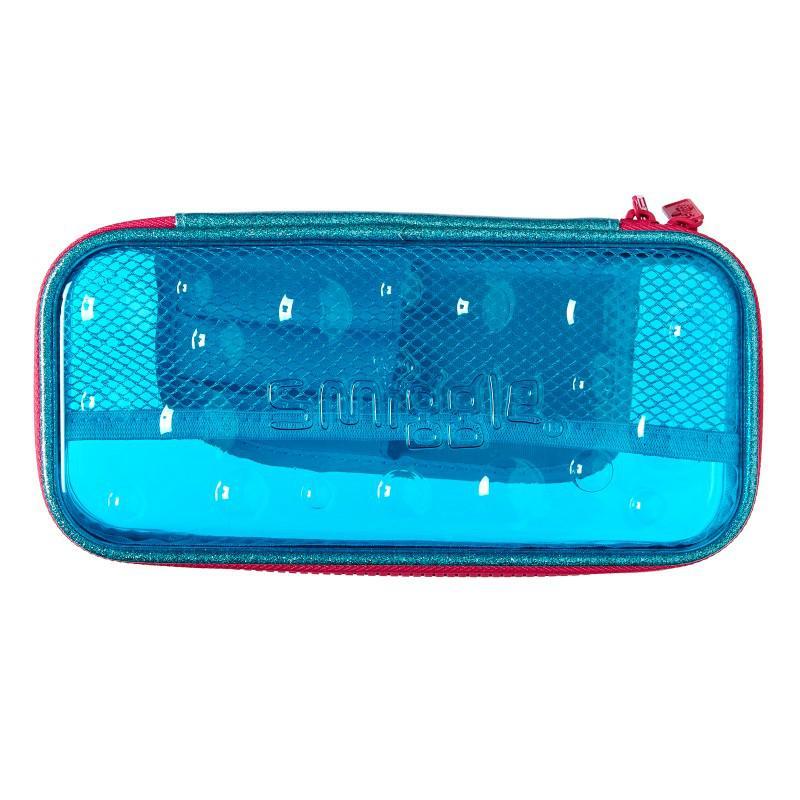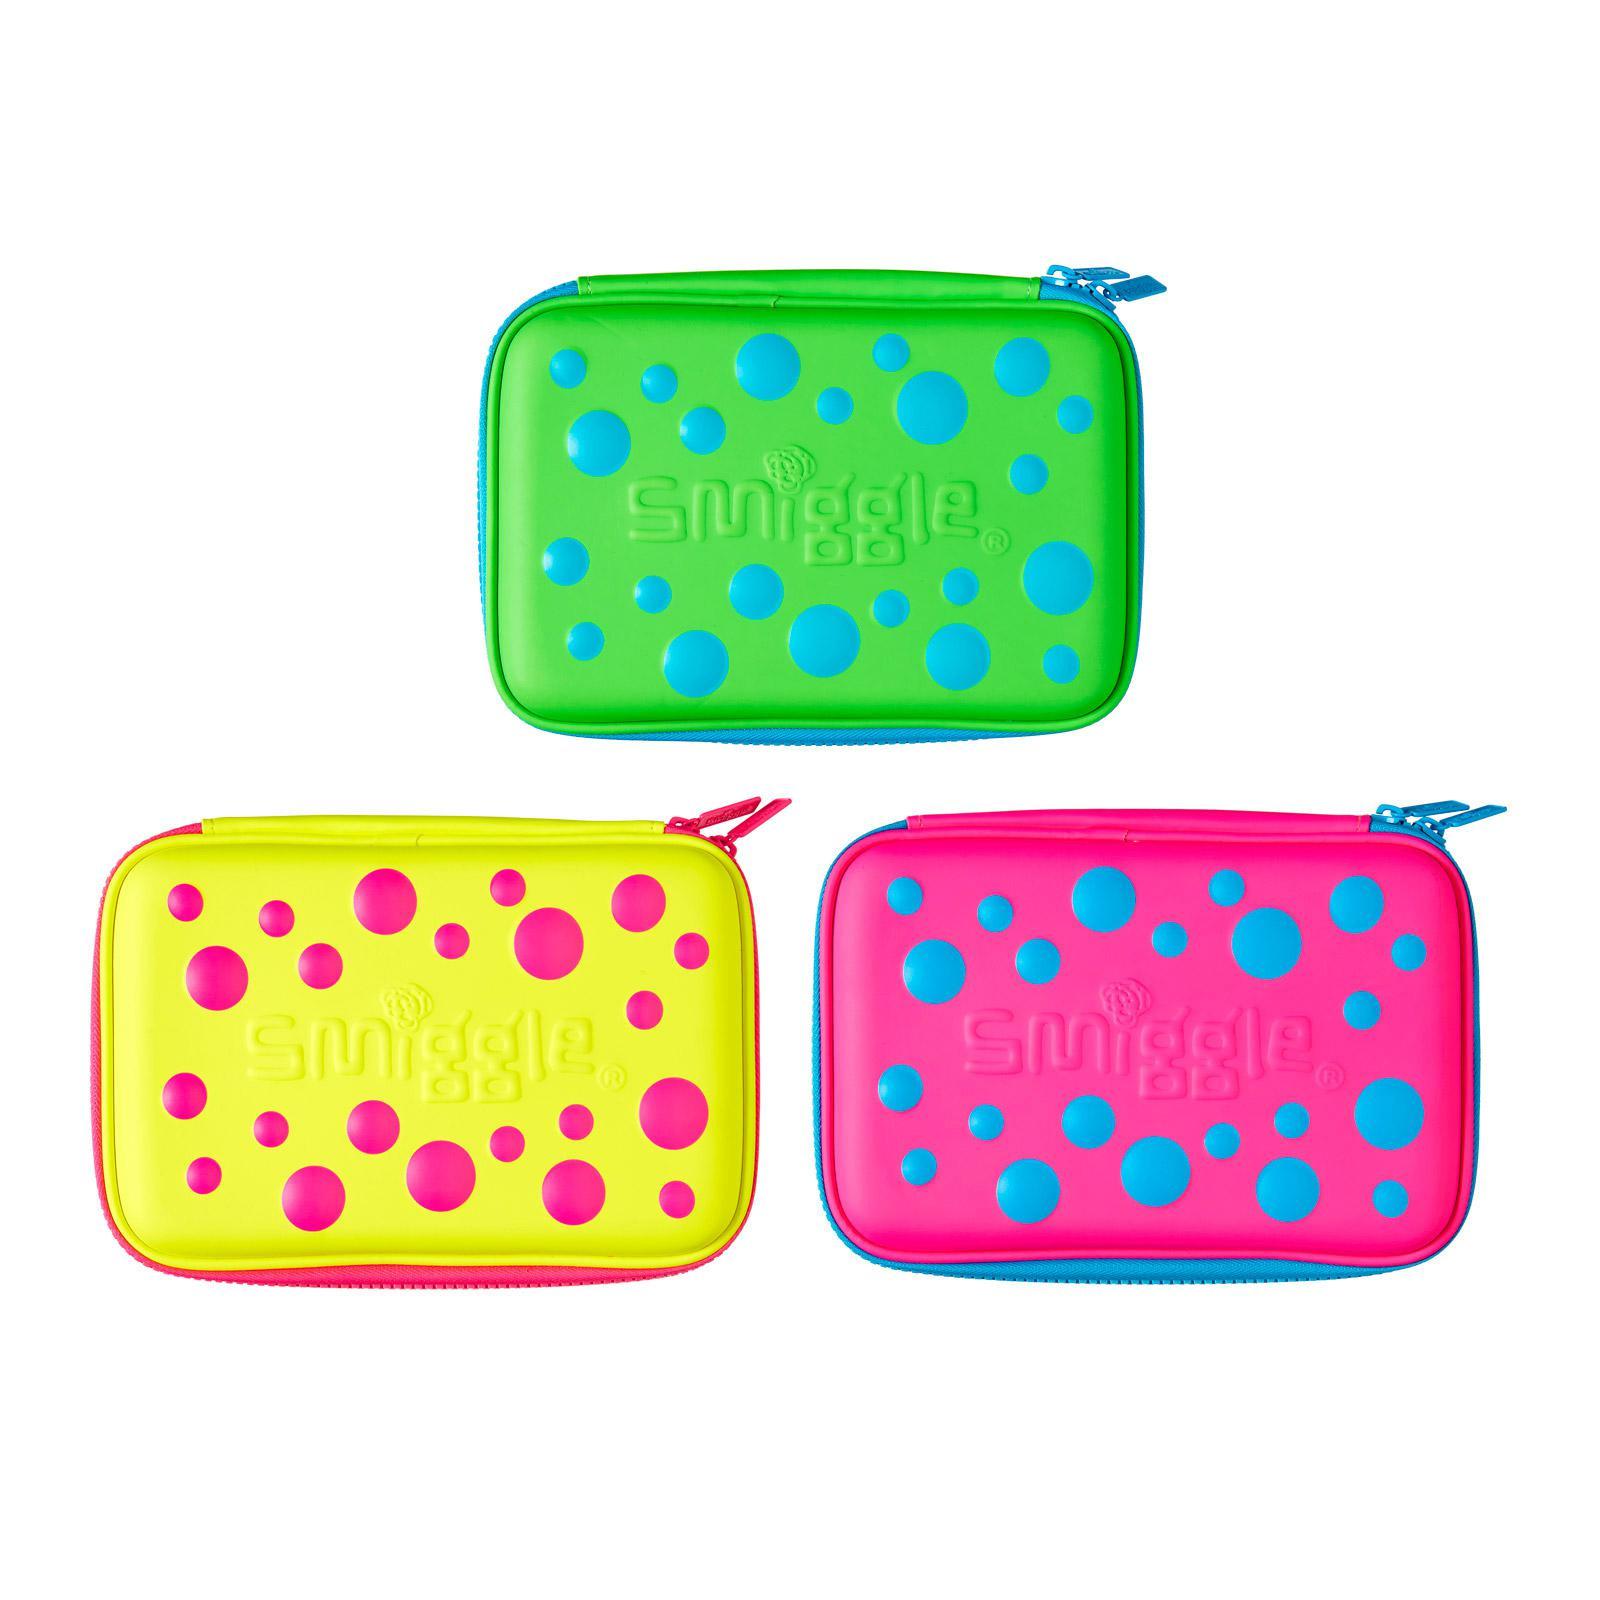The first image is the image on the left, the second image is the image on the right. For the images shown, is this caption "There is at least one pencil case open with no visible stationery inside." true? Answer yes or no. No. 